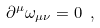Convert formula to latex. <formula><loc_0><loc_0><loc_500><loc_500>\partial ^ { \mu } \omega _ { \mu \nu } = 0 \ ,</formula> 